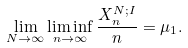Convert formula to latex. <formula><loc_0><loc_0><loc_500><loc_500>\lim _ { N \to \infty } \liminf _ { n \to \infty } \frac { X ^ { N ; I } _ { n } } n = \mu _ { 1 } .</formula> 